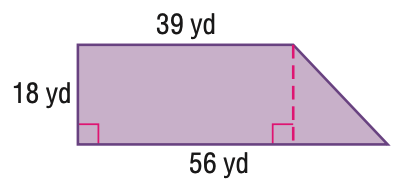Question: Find the area of the figure. Round to the nearest tenth if necessary.
Choices:
A. 702
B. 855
C. 1008
D. 1710
Answer with the letter. Answer: B 